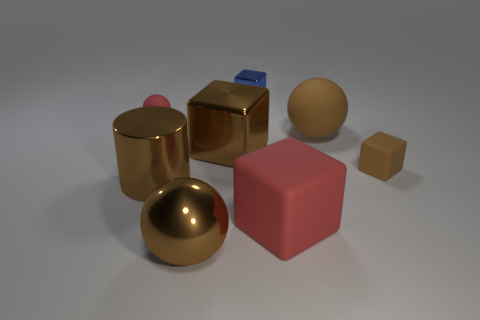What material is the small brown object that is the same shape as the blue shiny object?
Provide a short and direct response. Rubber. There is a tiny object on the left side of the large brown metallic cube; does it have the same color as the small rubber object that is in front of the red sphere?
Your answer should be compact. No. The big matte object behind the small brown thing has what shape?
Your response must be concise. Sphere. The small rubber block is what color?
Make the answer very short. Brown. What is the shape of the large brown thing that is the same material as the small ball?
Offer a terse response. Sphere. Do the red thing to the left of the red block and the large brown metallic ball have the same size?
Offer a terse response. No. How many things are balls left of the red block or small metal things to the left of the big red object?
Provide a short and direct response. 3. Is the color of the metallic block that is in front of the tiny shiny cube the same as the big cylinder?
Your response must be concise. Yes. What number of metallic objects are either spheres or small blocks?
Keep it short and to the point. 2. What is the shape of the big red object?
Keep it short and to the point. Cube. 